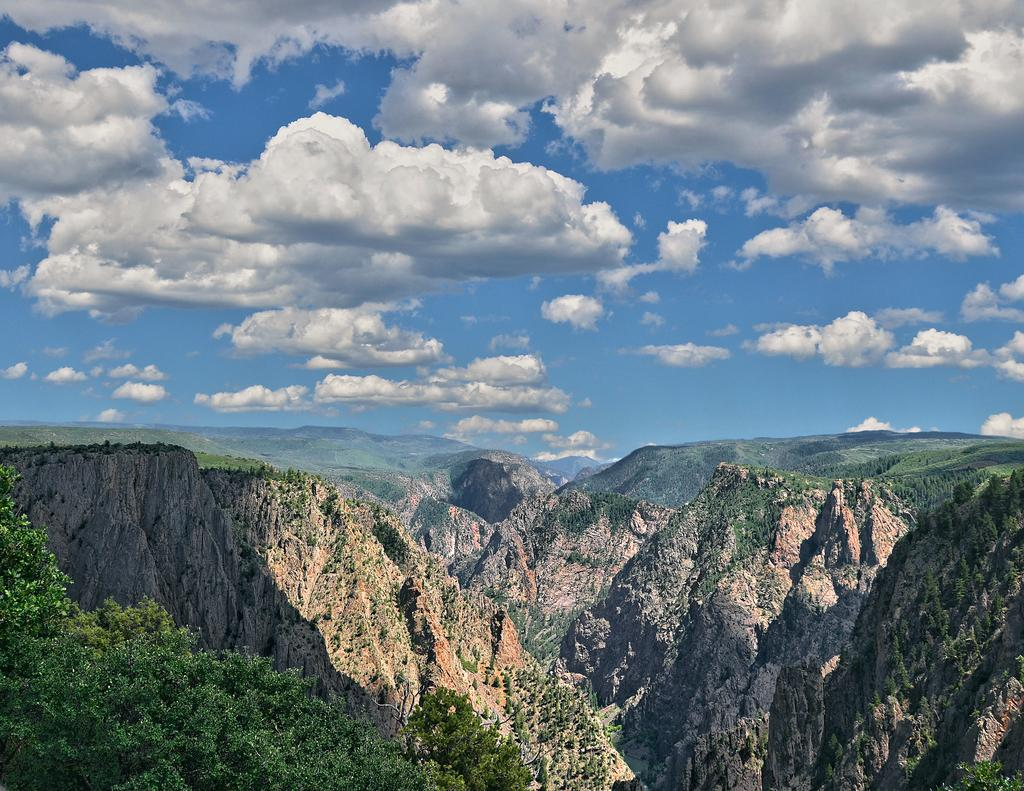What type of natural features can be seen in the image? There are trees and mountains in the image. What is visible in the background of the image? The sky is visible in the background of the image. How many chairs are present in the image? There are no chairs visible in the image. What type of balloon can be seen floating in the sky in the image? There is no balloon present in the image; only trees, mountains, and the sky are visible. 